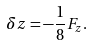Convert formula to latex. <formula><loc_0><loc_0><loc_500><loc_500>\delta z = - \frac { 1 } { 8 } { F _ { z } } .</formula> 